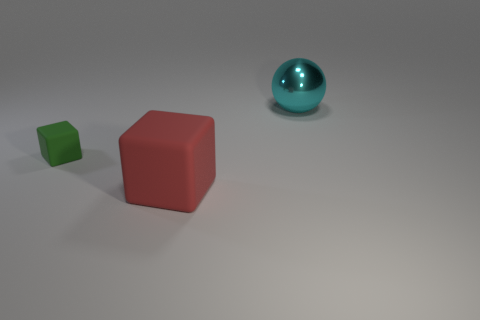Add 1 large blue shiny blocks. How many objects exist? 4 Subtract 1 blocks. How many blocks are left? 1 Subtract all blocks. How many objects are left? 1 Subtract all green blocks. How many blocks are left? 1 Subtract 0 brown blocks. How many objects are left? 3 Subtract all purple balls. Subtract all blue blocks. How many balls are left? 1 Subtract all tiny purple matte spheres. Subtract all small blocks. How many objects are left? 2 Add 3 metal things. How many metal things are left? 4 Add 1 blue metal blocks. How many blue metal blocks exist? 1 